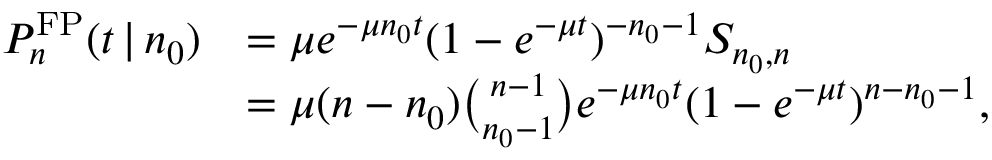<formula> <loc_0><loc_0><loc_500><loc_500>\begin{array} { r l } { P _ { n } ^ { F P } ( t \, | \, n _ { 0 } ) } & { = \mu e ^ { - \mu n _ { 0 } t } ( 1 - e ^ { - \mu t } ) ^ { - n _ { 0 } - 1 } S _ { n _ { 0 } , n } } \\ & { = \mu ( n - n _ { 0 } ) { \binom { n - 1 } { n _ { 0 } - 1 } } e ^ { - \mu n _ { 0 } t } ( 1 - e ^ { - \mu t } ) ^ { n - n _ { 0 } - 1 } , } \end{array}</formula> 